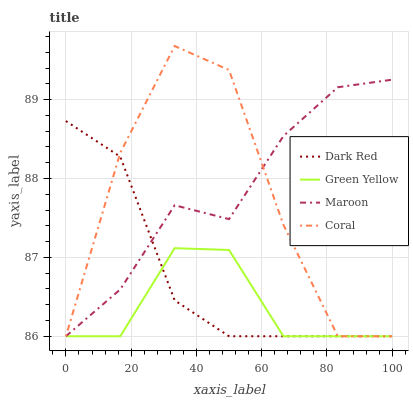Does Green Yellow have the minimum area under the curve?
Answer yes or no. Yes. Does Maroon have the maximum area under the curve?
Answer yes or no. Yes. Does Coral have the minimum area under the curve?
Answer yes or no. No. Does Coral have the maximum area under the curve?
Answer yes or no. No. Is Dark Red the smoothest?
Answer yes or no. Yes. Is Coral the roughest?
Answer yes or no. Yes. Is Green Yellow the smoothest?
Answer yes or no. No. Is Green Yellow the roughest?
Answer yes or no. No. Does Dark Red have the lowest value?
Answer yes or no. Yes. Does Coral have the highest value?
Answer yes or no. Yes. Does Green Yellow have the highest value?
Answer yes or no. No. Does Coral intersect Dark Red?
Answer yes or no. Yes. Is Coral less than Dark Red?
Answer yes or no. No. Is Coral greater than Dark Red?
Answer yes or no. No. 